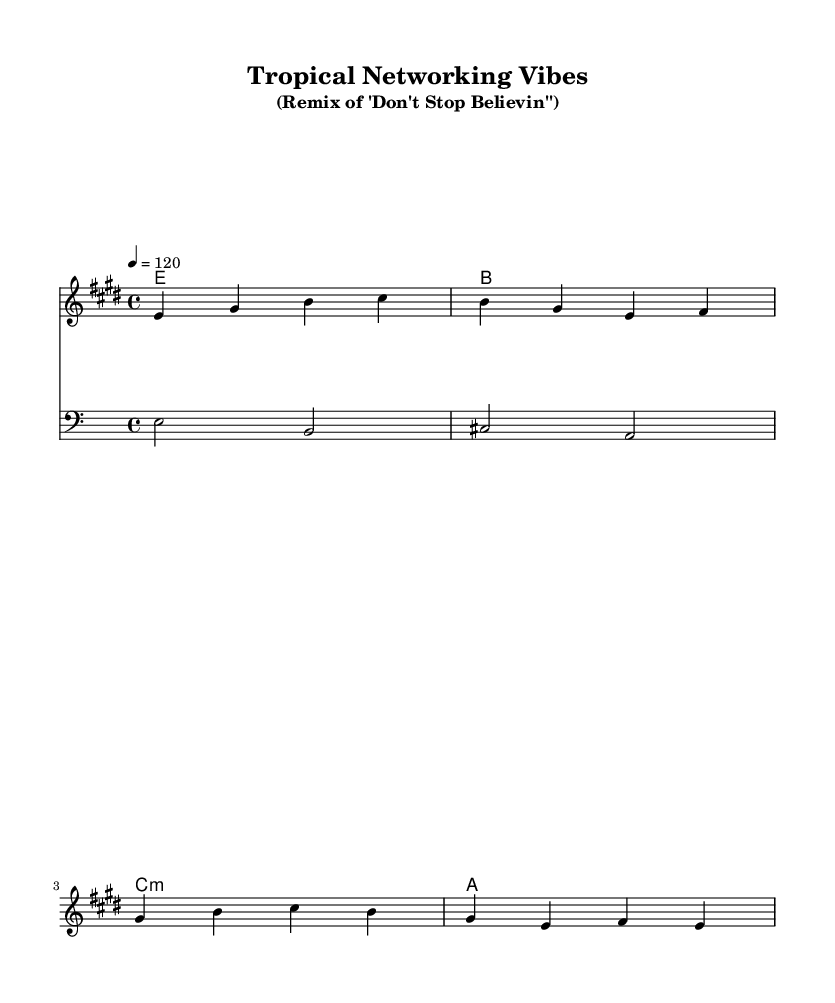What is the key signature of this music? The key signature is E major, which has four sharps: F sharp, C sharp, G sharp, and D sharp. This is indicated at the beginning of the staff.
Answer: E major What is the time signature of this music? The time signature is 4/4, which means there are four beats in each measure and the quarter note gets one beat. This is clearly marked at the start of the score.
Answer: 4/4 What is the tempo indication for this piece? The tempo is marked at 120 beats per minute, shown at the beginning of the score, indicating a moderately fast pace for the music.
Answer: 120 How many measures are in the score? The score consists of four measures, which can be counted by looking at the division of the staff into sections with bar lines.
Answer: Four What is the main key for the harmony part? The harmony part is primarily centered around E major, as seen from the chord layout of E major, B major, C minor, and A major throughout the score.
Answer: E major What kind of music genre does this remix belong to? This remix fits into the tropical house genre, characterized by its laid-back beats and melodic elements that enhance the classic pop vibe.
Answer: Tropical house What role does the bass play in this arrangement? The bass part provides a foundation for the harmony by emphasizing the root notes of the chords, specifically playing E, B, C sharp, and A notes.
Answer: Foundation 